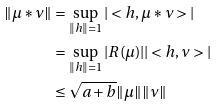<formula> <loc_0><loc_0><loc_500><loc_500>\| \mu \ast \nu \| & = \sup _ { \| h \| = 1 } | < h , \mu \ast \nu > | \\ & = \sup _ { \| h \| = 1 } | R ( \mu ) | | < h , \nu > | \\ & \leq \sqrt { a + b } \| \mu \| \| \nu \|</formula> 